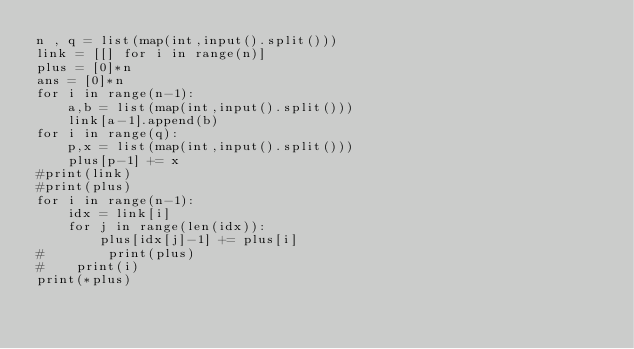<code> <loc_0><loc_0><loc_500><loc_500><_Python_>n , q = list(map(int,input().split()))
link = [[] for i in range(n)]
plus = [0]*n
ans = [0]*n
for i in range(n-1):
    a,b = list(map(int,input().split()))
    link[a-1].append(b)
for i in range(q):
    p,x = list(map(int,input().split()))
    plus[p-1] += x
#print(link)
#print(plus)
for i in range(n-1):
    idx = link[i]
    for j in range(len(idx)):
        plus[idx[j]-1] += plus[i]
#        print(plus)
#    print(i)
print(*plus)</code> 